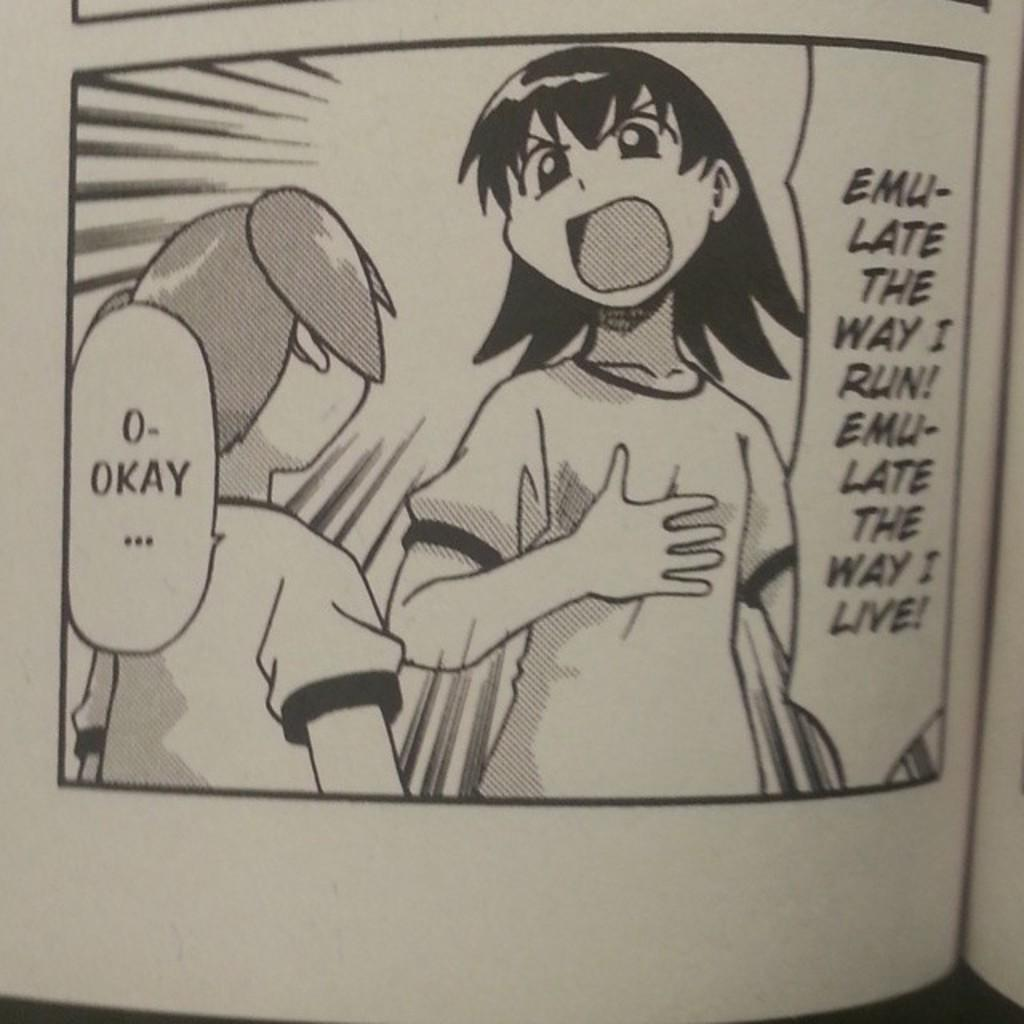What is the main object in the image? There is a book in the image. What type of content is present in the book? The book contains images of persons and text. How many goldfish are swimming in the book in the image? There are no goldfish present in the image, as it features a book with images of persons and text. 